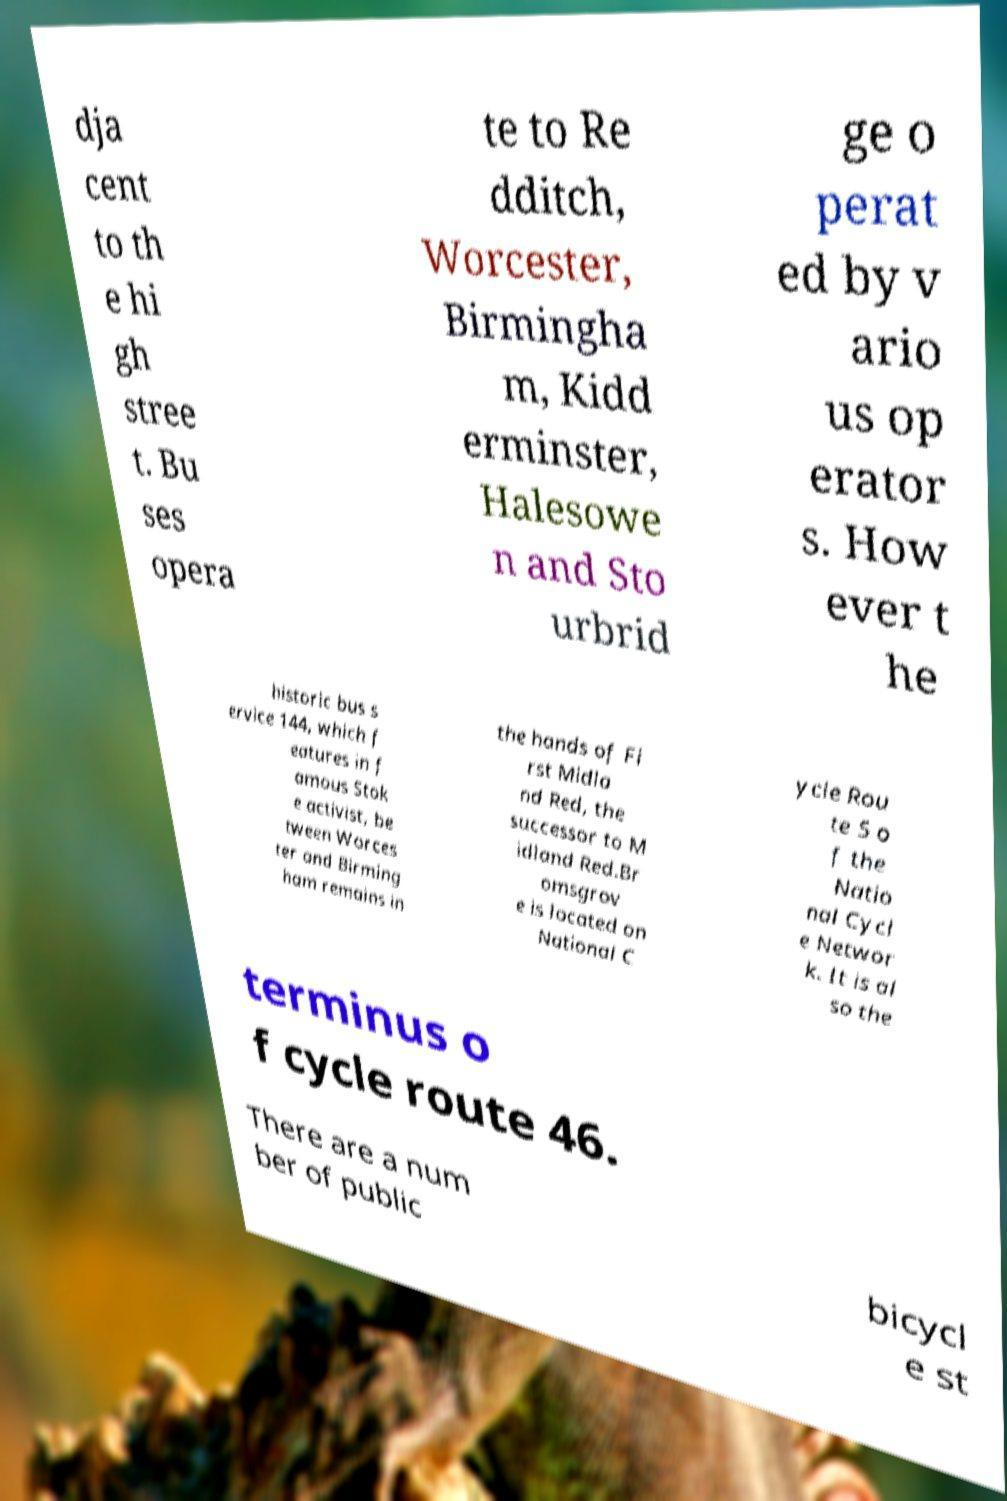Could you assist in decoding the text presented in this image and type it out clearly? dja cent to th e hi gh stree t. Bu ses opera te to Re dditch, Worcester, Birmingha m, Kidd erminster, Halesowe n and Sto urbrid ge o perat ed by v ario us op erator s. How ever t he historic bus s ervice 144, which f eatures in f amous Stok e activist, be tween Worces ter and Birming ham remains in the hands of Fi rst Midla nd Red, the successor to M idland Red.Br omsgrov e is located on National C ycle Rou te 5 o f the Natio nal Cycl e Networ k. It is al so the terminus o f cycle route 46. There are a num ber of public bicycl e st 